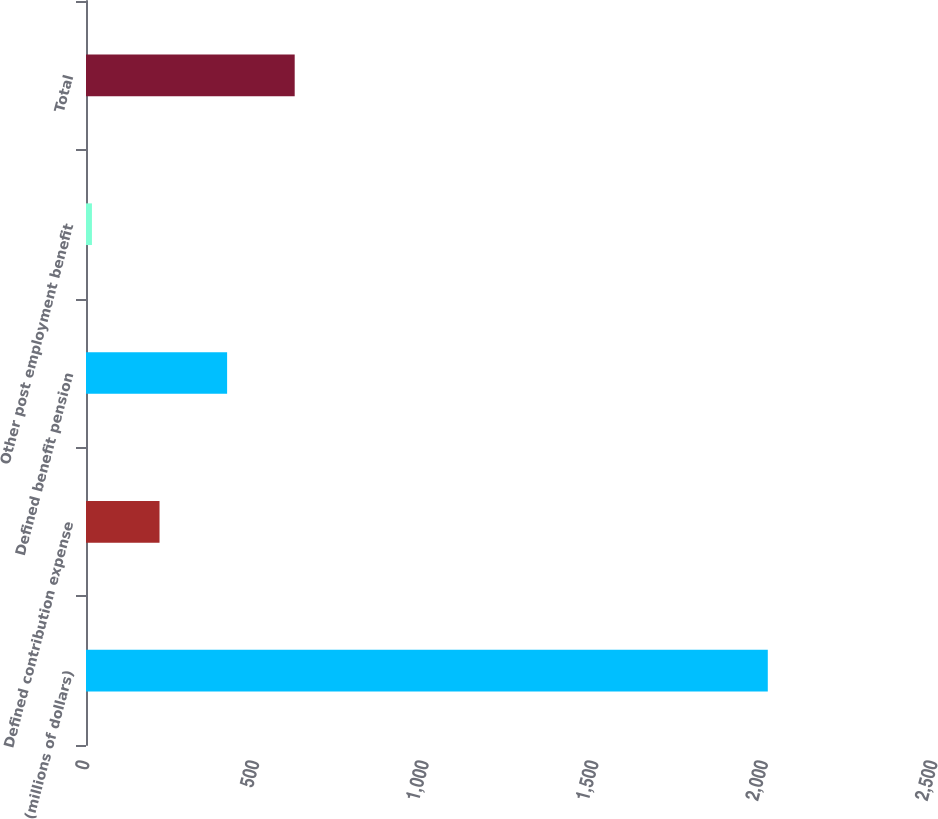<chart> <loc_0><loc_0><loc_500><loc_500><bar_chart><fcel>(millions of dollars)<fcel>Defined contribution expense<fcel>Defined benefit pension<fcel>Other post employment benefit<fcel>Total<nl><fcel>2010<fcel>216.75<fcel>416<fcel>17.5<fcel>615.25<nl></chart> 